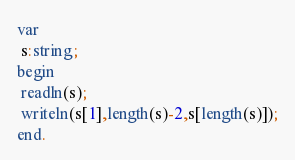Convert code to text. <code><loc_0><loc_0><loc_500><loc_500><_Pascal_>var
 s:string;
begin
 readln(s);
 writeln(s[1],length(s)-2,s[length(s)]);
end.</code> 